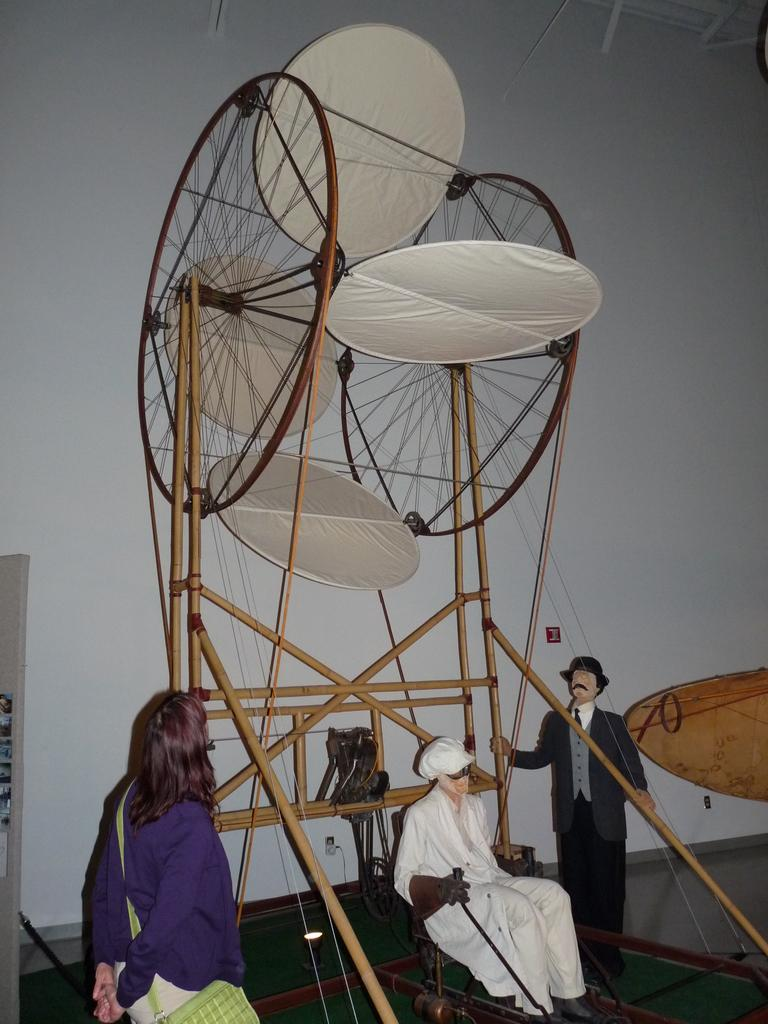What is the main subject of the image? The main subject of the image is a depiction of persons. What else can be seen in the image besides the persons? There is a flying machine in the image. Can you describe the position of one of the persons in the image? There is a person in the bottom left of the image. What is the person wearing in the image? The person is wearing clothes and a bag. What type of vacation is the person in the image planning to go on? There is no indication in the image that the person is planning a vacation, so it cannot be determined from the picture. 